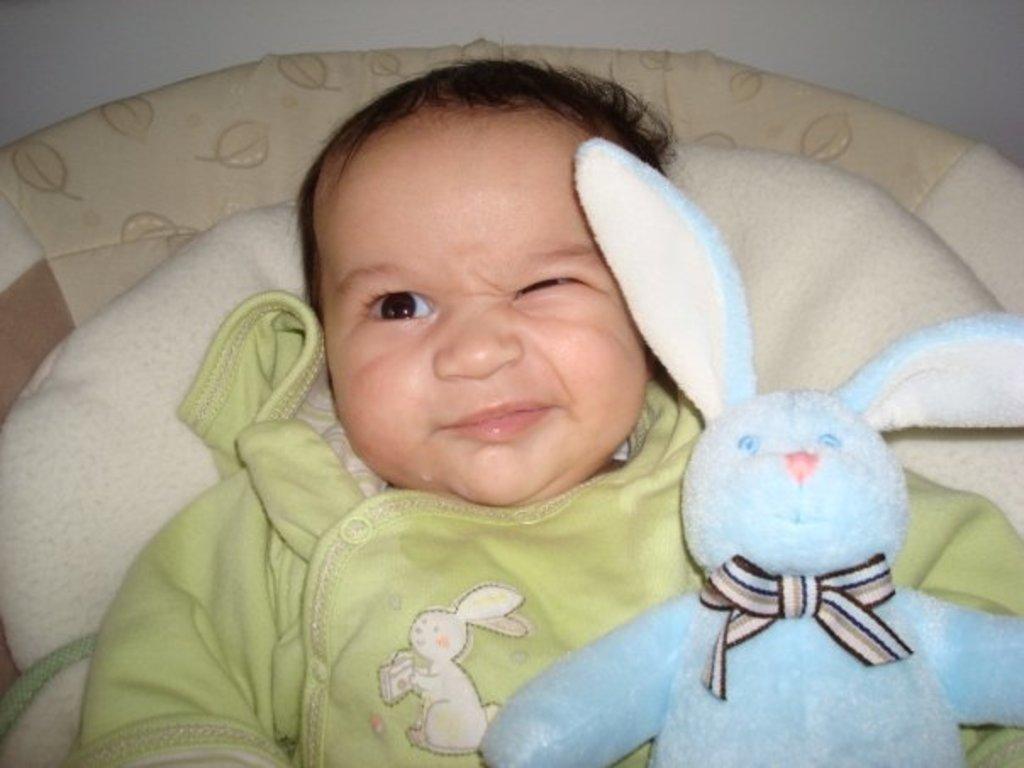Could you give a brief overview of what you see in this image? In this picture we can see a baby laying here, there is a teddy bear here, in the background there is a wall. 